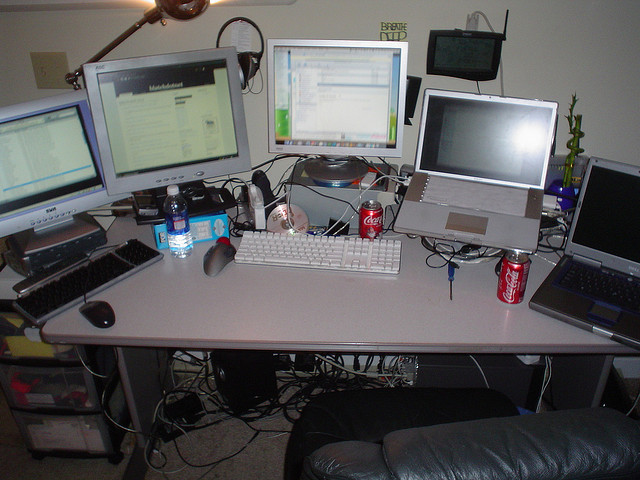Please transcribe the text in this image. TD BREATH 